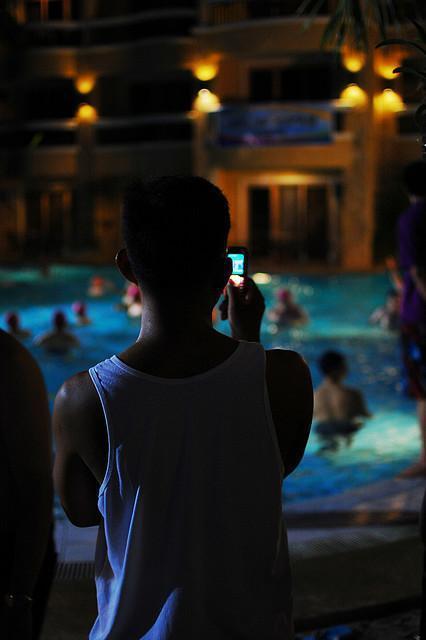How many motorcycle riders are there?
Give a very brief answer. 0. How many items does the man carry?
Give a very brief answer. 1. How many lights are in this room?
Give a very brief answer. 4. How many people can you see?
Give a very brief answer. 4. How many motorcycles are in the picture?
Give a very brief answer. 0. 